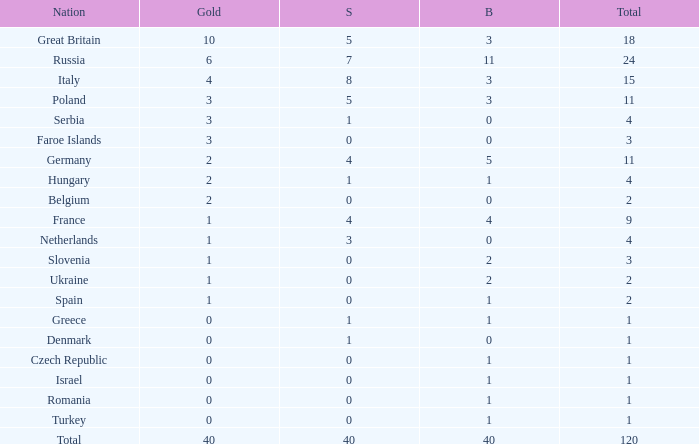What Nation has a Gold entry that is greater than 0, a Total that is greater than 2, a Silver entry that is larger than 1, and 0 Bronze? Netherlands. 